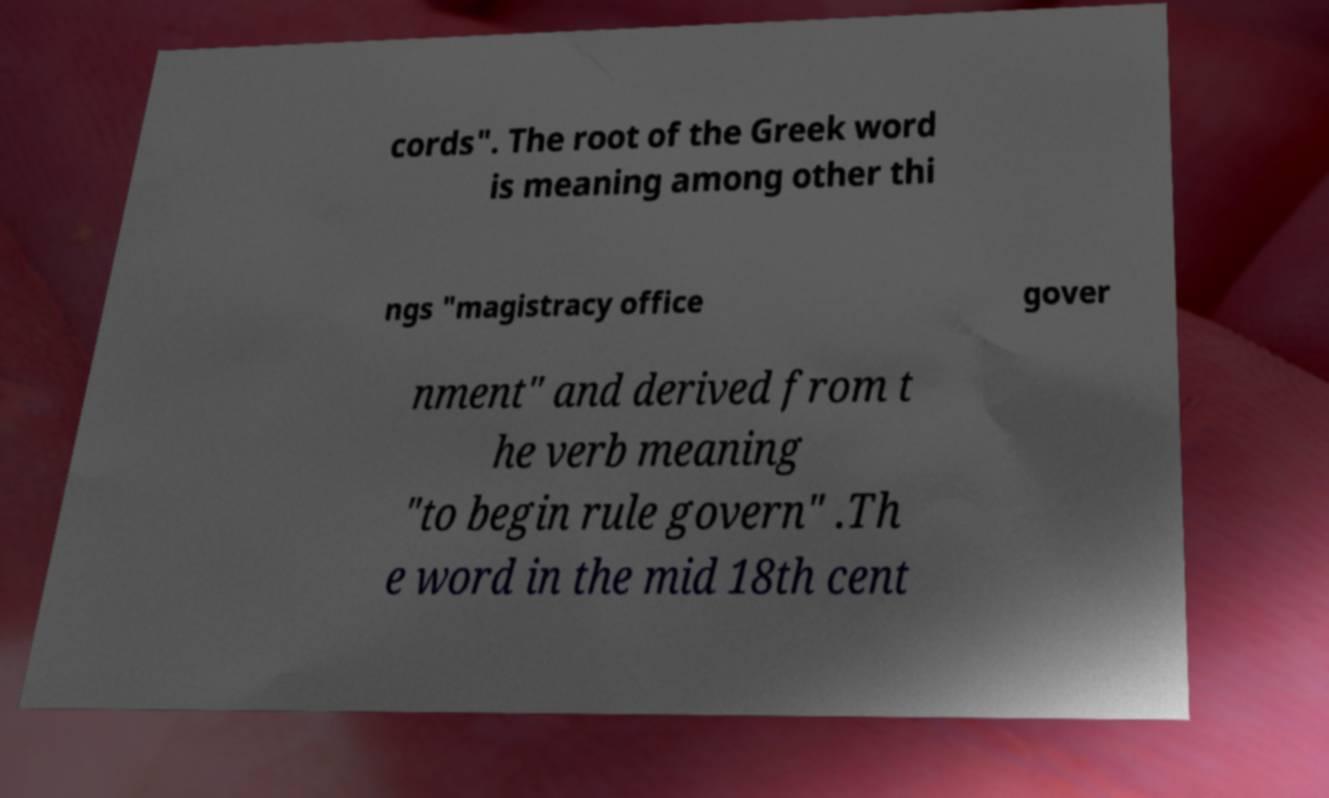Could you extract and type out the text from this image? cords". The root of the Greek word is meaning among other thi ngs "magistracy office gover nment" and derived from t he verb meaning "to begin rule govern" .Th e word in the mid 18th cent 